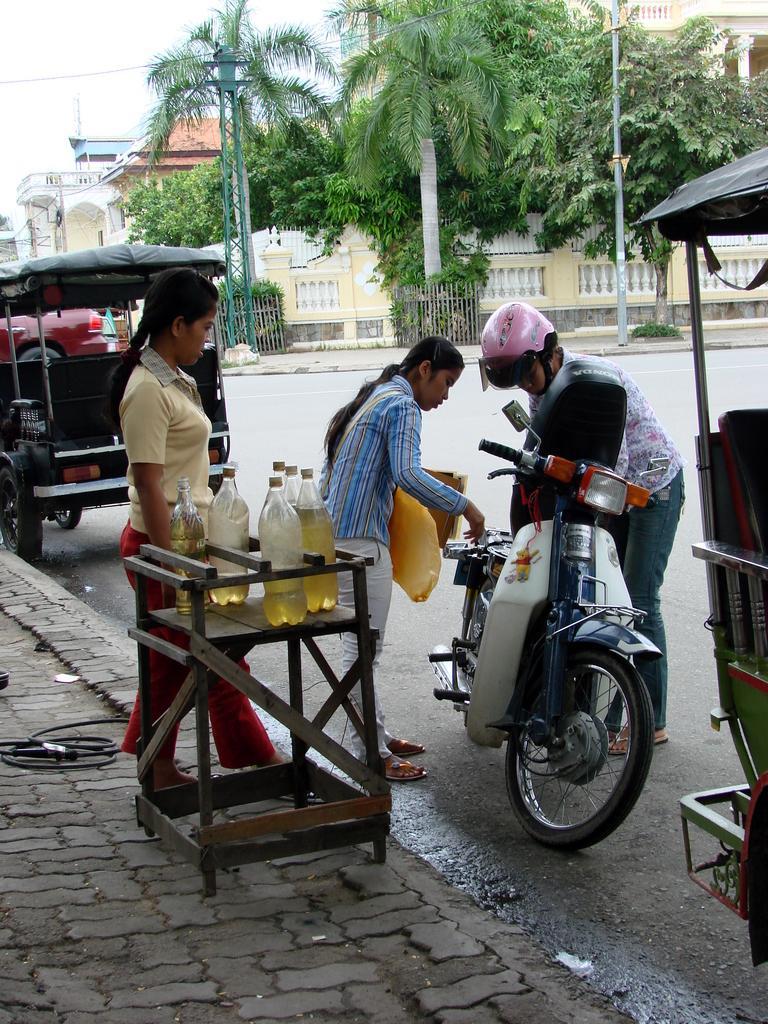How would you summarize this image in a sentence or two? In this picture we can see three people standing on the ground, bottles, table, scooter, vehicles, poles, trees, buildings and in the background we can see the sky. 